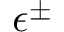<formula> <loc_0><loc_0><loc_500><loc_500>\epsilon ^ { \pm }</formula> 